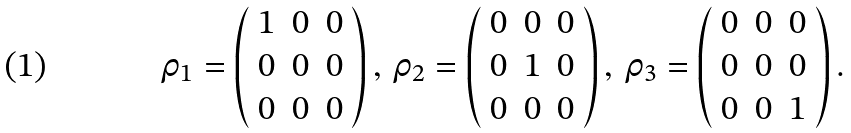<formula> <loc_0><loc_0><loc_500><loc_500>\rho _ { 1 } = \left ( \begin{array} { l c r } 1 & 0 & 0 \\ 0 & 0 & 0 \\ 0 & 0 & 0 \end{array} \right ) , \, \rho _ { 2 } = \left ( \begin{array} { l c r r } 0 & 0 & 0 \\ 0 & 1 & 0 \\ 0 & 0 & 0 \end{array} \right ) , \, \rho _ { 3 } = \left ( \begin{array} { l c r } 0 & 0 & 0 \\ 0 & 0 & 0 \\ 0 & 0 & 1 \end{array} \right ) .</formula> 